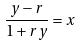Convert formula to latex. <formula><loc_0><loc_0><loc_500><loc_500>\frac { y - r } { 1 + r y } = x</formula> 